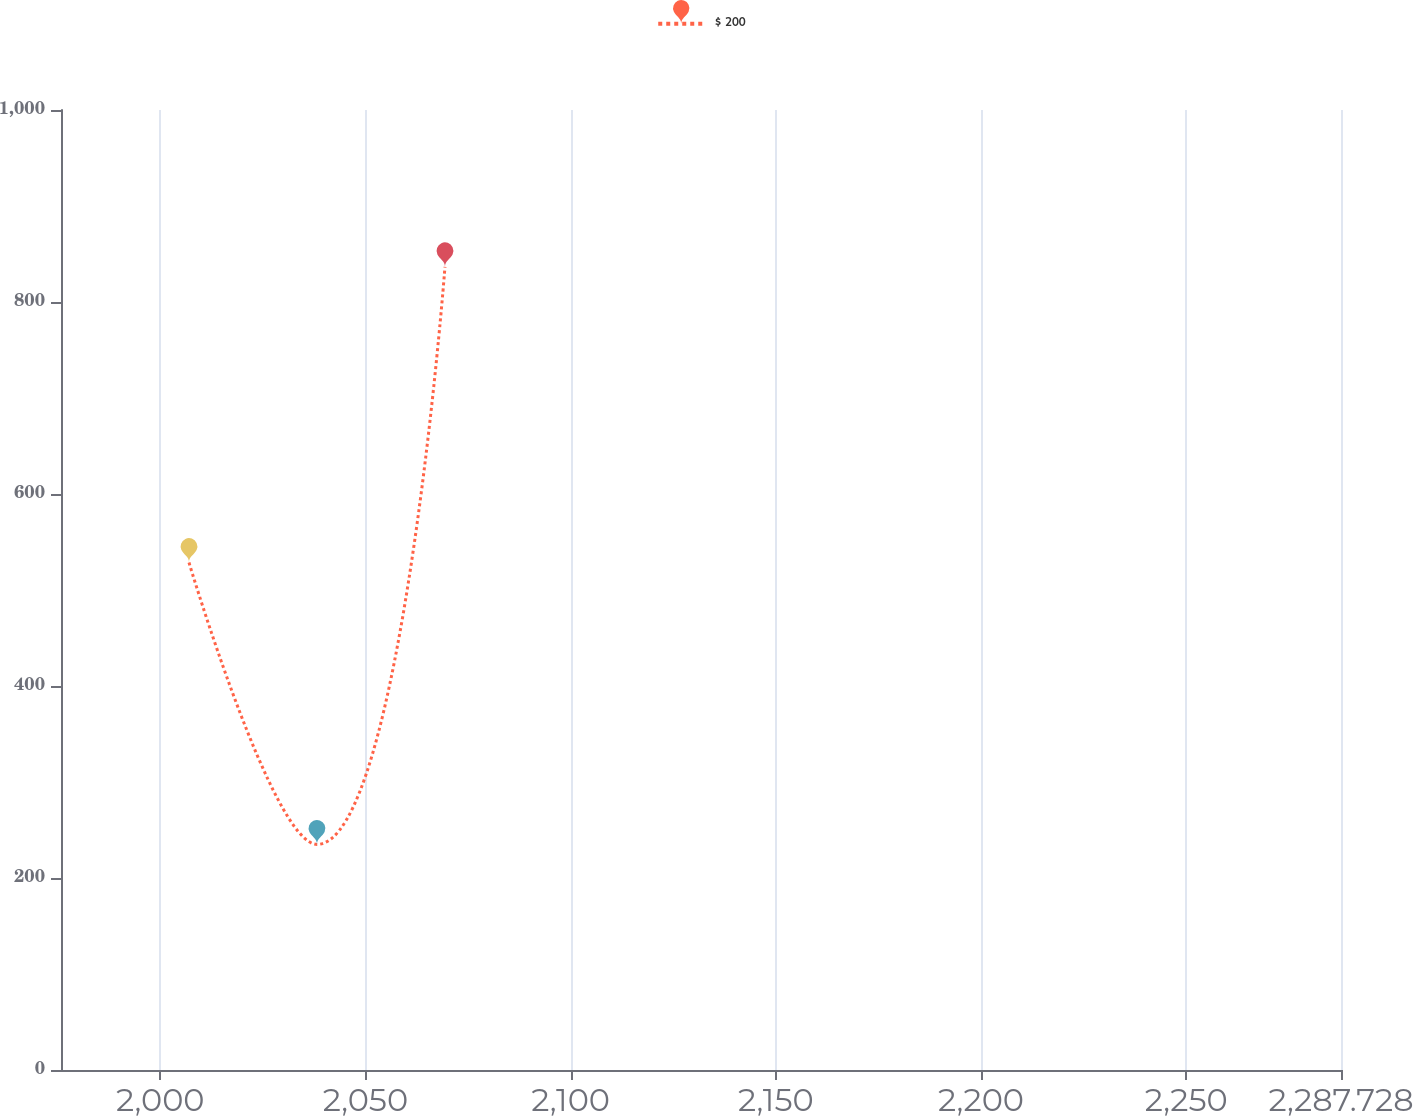Convert chart to OTSL. <chart><loc_0><loc_0><loc_500><loc_500><line_chart><ecel><fcel>$ 200<nl><fcel>2007<fcel>528.62<nl><fcel>2038.19<fcel>235<nl><fcel>2069.38<fcel>836.69<nl><fcel>2318.92<fcel>383.26<nl></chart> 